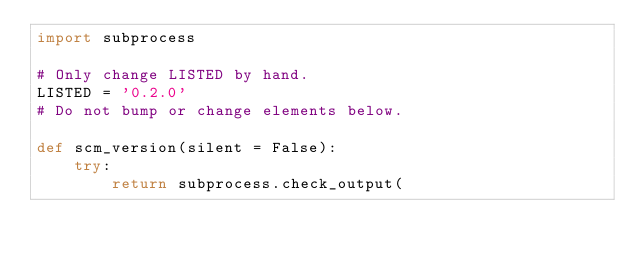<code> <loc_0><loc_0><loc_500><loc_500><_Python_>import subprocess

# Only change LISTED by hand.
LISTED = '0.2.0'
# Do not bump or change elements below.

def scm_version(silent = False):
    try:
        return subprocess.check_output(</code> 